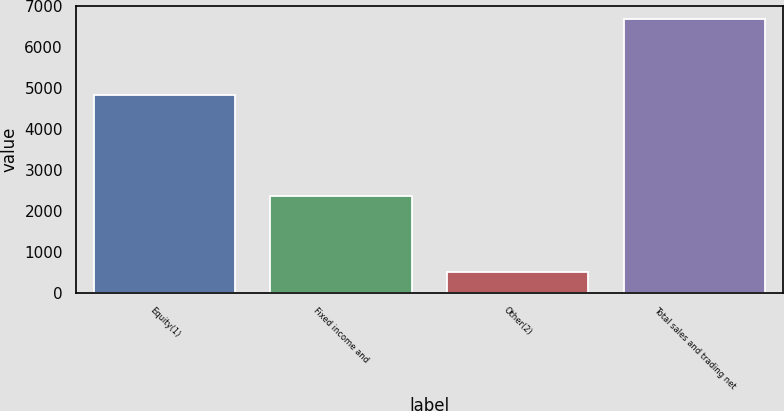Convert chart to OTSL. <chart><loc_0><loc_0><loc_500><loc_500><bar_chart><fcel>Equity(1)<fcel>Fixed income and<fcel>Other(2)<fcel>Total sales and trading net<nl><fcel>4811<fcel>2358<fcel>496<fcel>6673<nl></chart> 